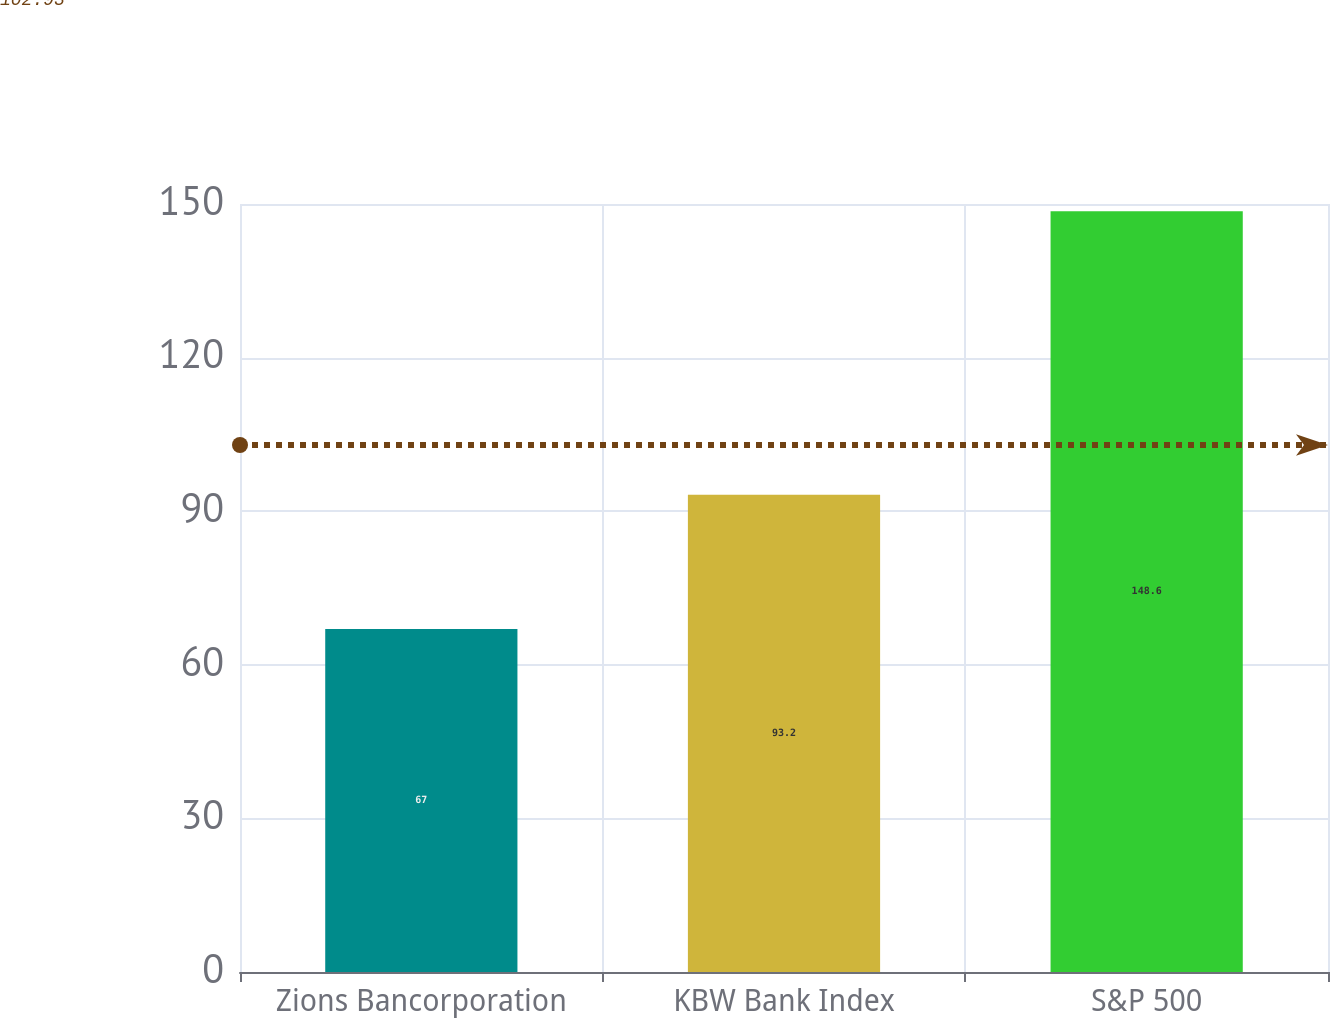Convert chart to OTSL. <chart><loc_0><loc_0><loc_500><loc_500><bar_chart><fcel>Zions Bancorporation<fcel>KBW Bank Index<fcel>S&P 500<nl><fcel>67<fcel>93.2<fcel>148.6<nl></chart> 